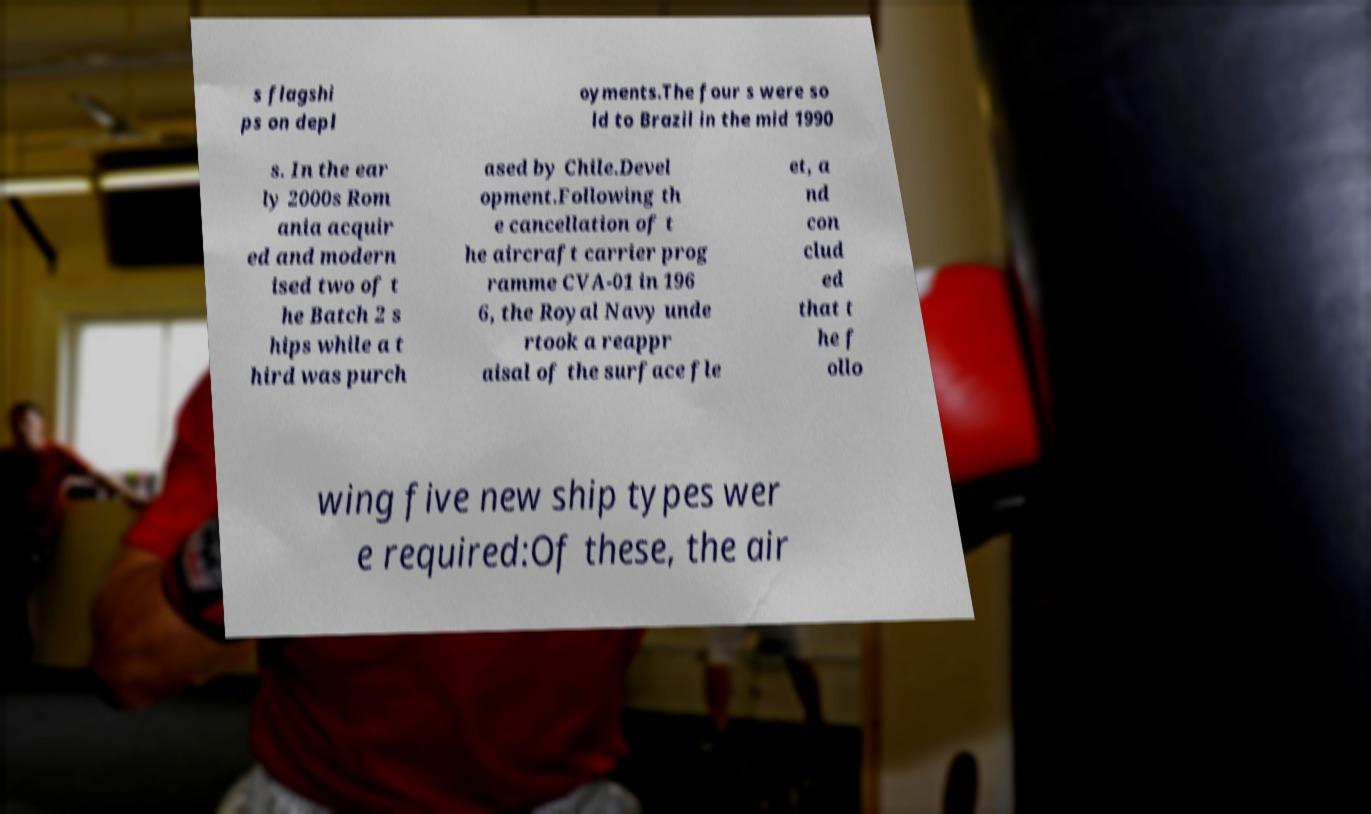Could you assist in decoding the text presented in this image and type it out clearly? s flagshi ps on depl oyments.The four s were so ld to Brazil in the mid 1990 s. In the ear ly 2000s Rom ania acquir ed and modern ised two of t he Batch 2 s hips while a t hird was purch ased by Chile.Devel opment.Following th e cancellation of t he aircraft carrier prog ramme CVA-01 in 196 6, the Royal Navy unde rtook a reappr aisal of the surface fle et, a nd con clud ed that t he f ollo wing five new ship types wer e required:Of these, the air 